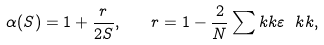<formula> <loc_0><loc_0><loc_500><loc_500>\alpha ( S ) = 1 + \frac { r } { 2 S } , \quad r = 1 - \frac { 2 } { N } \sum _ { \ } k k \varepsilon _ { \ } k k ,</formula> 